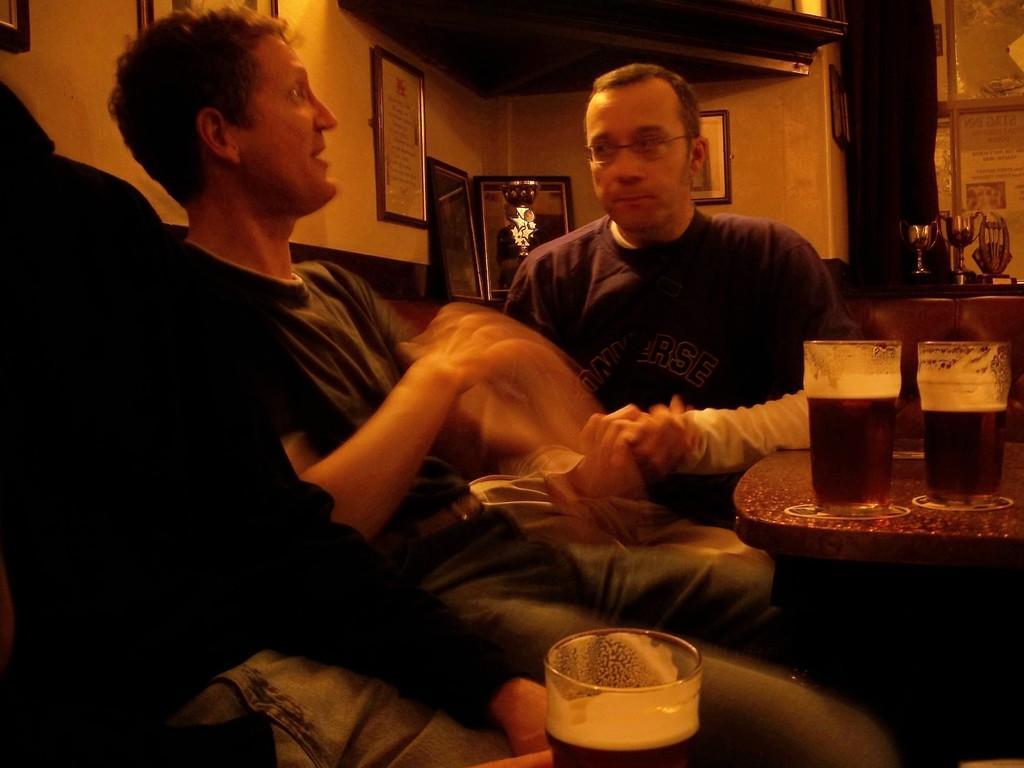Can you describe this image briefly? In this image there are few men sitting in the chairs. On the right side there is a table on which there are two glasses. In the background there is a wall on which there are photo frames. On the right side there are three shields kept on the desk. Beside the shields there is a curtain. On the left side there is a man who is holding the glass with some drink in it. 